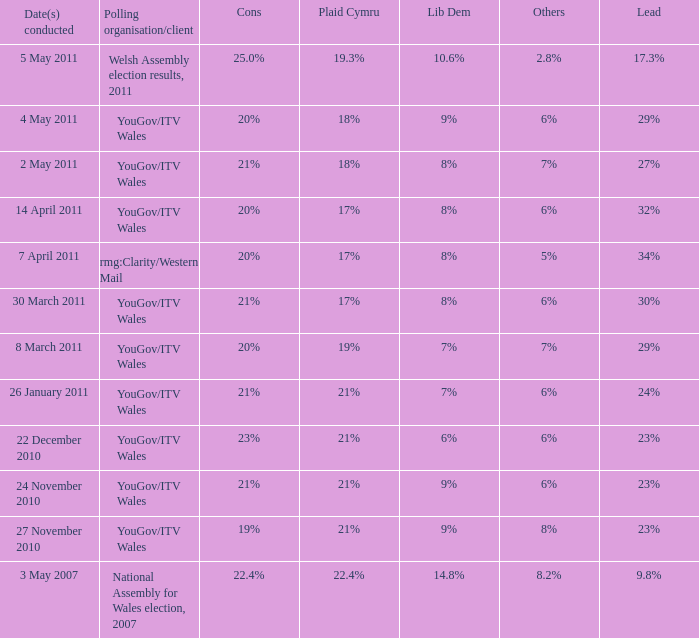Identify the alternatives for disadvantages of 21% and advantage of 24% 6%. 